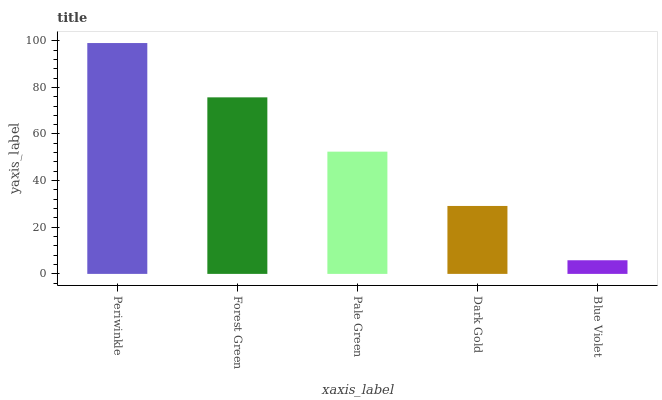Is Blue Violet the minimum?
Answer yes or no. Yes. Is Periwinkle the maximum?
Answer yes or no. Yes. Is Forest Green the minimum?
Answer yes or no. No. Is Forest Green the maximum?
Answer yes or no. No. Is Periwinkle greater than Forest Green?
Answer yes or no. Yes. Is Forest Green less than Periwinkle?
Answer yes or no. Yes. Is Forest Green greater than Periwinkle?
Answer yes or no. No. Is Periwinkle less than Forest Green?
Answer yes or no. No. Is Pale Green the high median?
Answer yes or no. Yes. Is Pale Green the low median?
Answer yes or no. Yes. Is Forest Green the high median?
Answer yes or no. No. Is Dark Gold the low median?
Answer yes or no. No. 